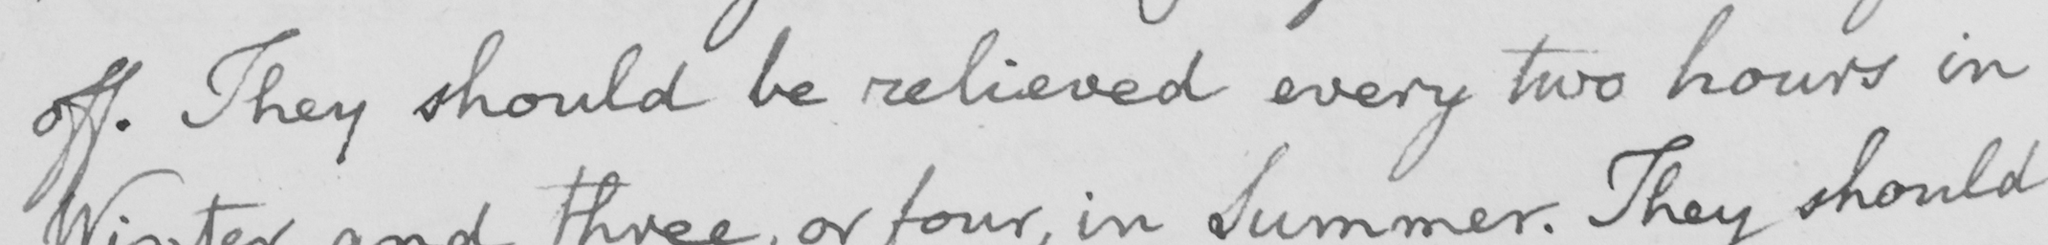Please transcribe the handwritten text in this image. off . They should be relieved every two hours in 